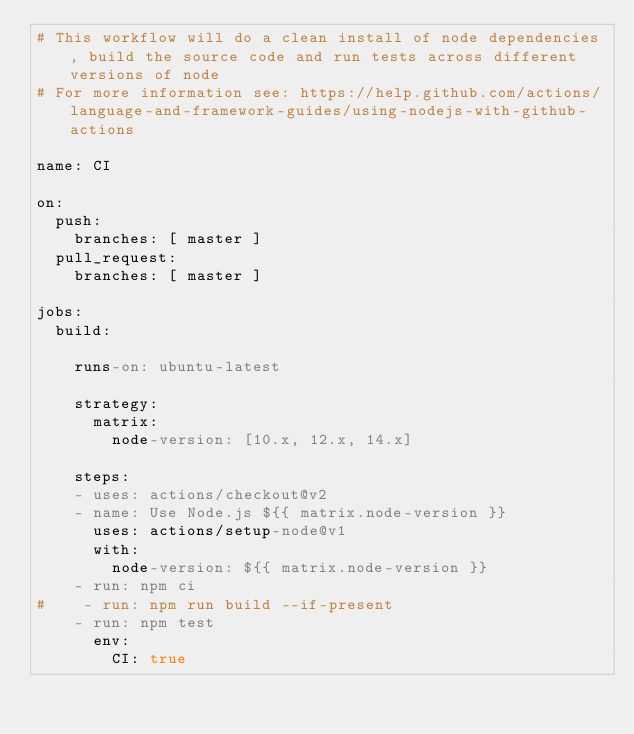<code> <loc_0><loc_0><loc_500><loc_500><_YAML_># This workflow will do a clean install of node dependencies, build the source code and run tests across different versions of node
# For more information see: https://help.github.com/actions/language-and-framework-guides/using-nodejs-with-github-actions

name: CI

on:
  push:
    branches: [ master ]
  pull_request:
    branches: [ master ]

jobs:
  build:

    runs-on: ubuntu-latest

    strategy:
      matrix:
        node-version: [10.x, 12.x, 14.x]

    steps:
    - uses: actions/checkout@v2
    - name: Use Node.js ${{ matrix.node-version }}
      uses: actions/setup-node@v1
      with:
        node-version: ${{ matrix.node-version }}
    - run: npm ci
#    - run: npm run build --if-present
    - run: npm test
      env:
        CI: true
</code> 